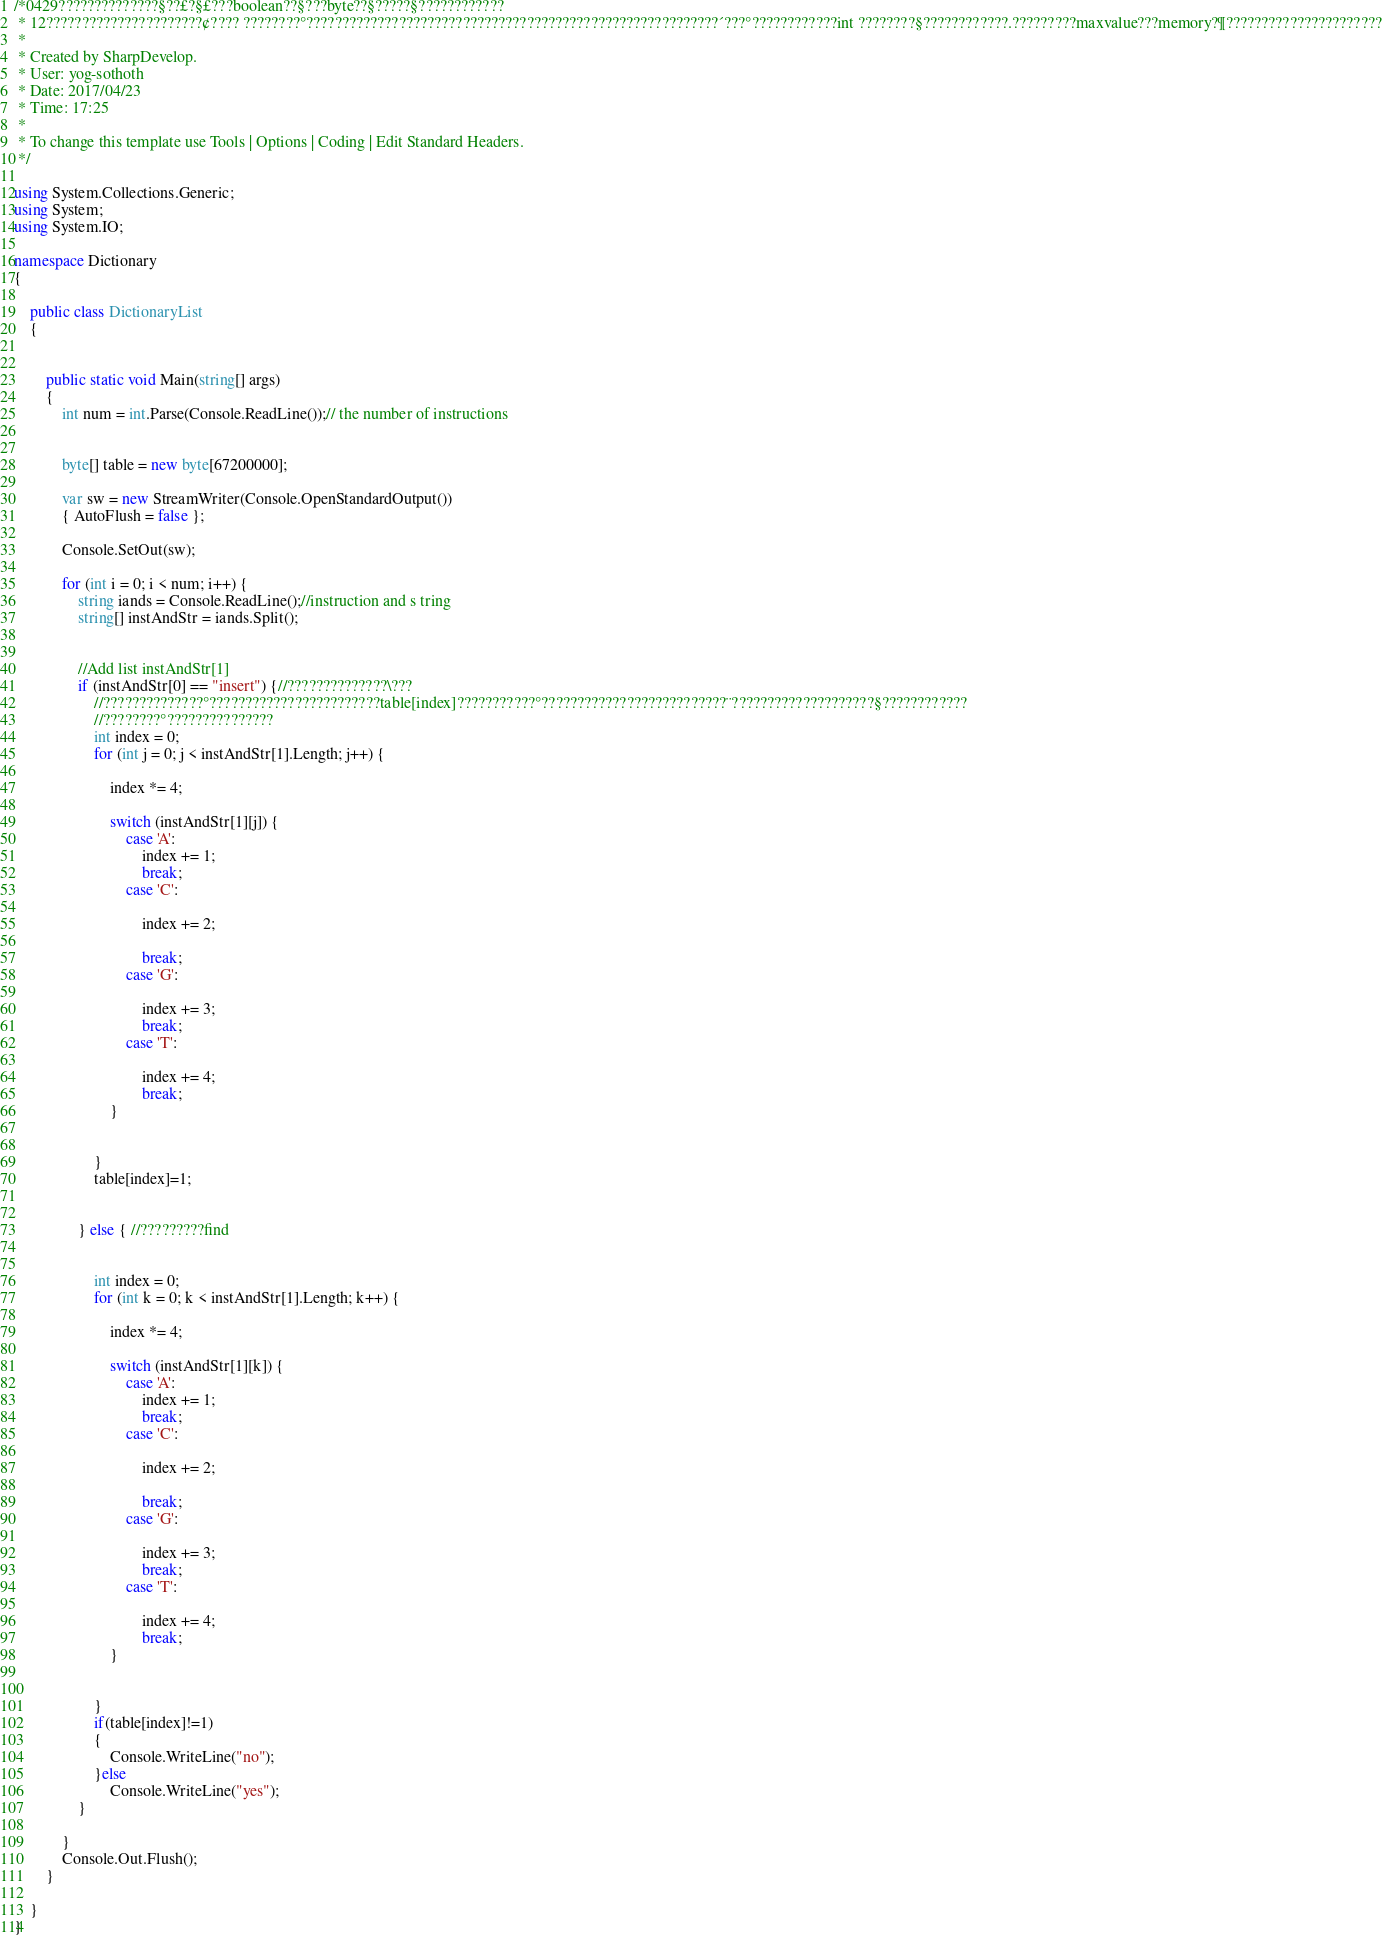Convert code to text. <code><loc_0><loc_0><loc_500><loc_500><_C#_>/*0429??????????????§??£?§£???boolean??§???byte??§?????§????????????
 * 12??????????????????????¢???? ????????°??????????????????????????????????????????????????????????´???°????????????int ????????§????????????.?????????maxvalue???memory?¶??????????????????????
 * 
 * Created by SharpDevelop.
 * User: yog-sothoth
 * Date: 2017/04/23
 * Time: 17:25
 * 
 * To change this template use Tools | Options | Coding | Edit Standard Headers.
 */

using System.Collections.Generic;
using System;
using System.IO;

namespace Dictionary
{
	
	public class DictionaryList
	{
		
		
		public static void Main(string[] args)
		{		
			int num = int.Parse(Console.ReadLine());// the number of instructions
			
			
			byte[] table = new byte[67200000];
		
			var sw = new StreamWriter(Console.OpenStandardOutput())
	    	{ AutoFlush = false };
			
			Console.SetOut(sw);
			
			for (int i = 0; i < num; i++) {
				string iands = Console.ReadLine();//instruction and s tring
				string[] instAndStr = iands.Split();
			
				
				//Add list instAndStr[1]		
				if (instAndStr[0] == "insert") {//??????????????\???
					//??????????????°????????????????????????table[index]???????????°??????????????????????????¨????????????????????§????????????
					//????????°???????????????
					int index = 0;
					for (int j = 0; j < instAndStr[1].Length; j++) {
			
						index *= 4;
				
						switch (instAndStr[1][j]) {
							case 'A':
								index += 1;
								break;
							case 'C':
						
								index += 2;
						
								break;
							case 'G':
						
								index += 3;
								break;
							case 'T':
						
								index += 4;
								break;			
						}
						
		
					}
					table[index]=1;
		
					
				} else { //?????????find
					
					
					int index = 0;
					for (int k = 0; k < instAndStr[1].Length; k++) {
			
						index *= 4;
				
						switch (instAndStr[1][k]) {
							case 'A':
								index += 1;
								break;
							case 'C':
						
								index += 2;
						
								break;
							case 'G':
						
								index += 3;
								break;
							case 'T':
						
								index += 4;
								break;			
						}
						
		
					}
					if(table[index]!=1)
					{
						Console.WriteLine("no");
					}else
						Console.WriteLine("yes");
				}
				
			}
			Console.Out.Flush();
		}
		
	}
}</code> 